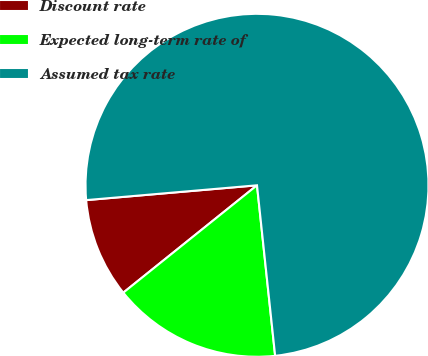Convert chart to OTSL. <chart><loc_0><loc_0><loc_500><loc_500><pie_chart><fcel>Discount rate<fcel>Expected long-term rate of<fcel>Assumed tax rate<nl><fcel>9.39%<fcel>15.92%<fcel>74.69%<nl></chart> 